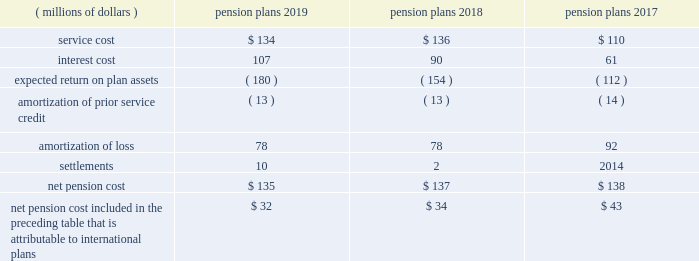Note 9 2014 benefit plans the company has defined benefit pension plans covering certain employees in the united states and certain international locations .
Postretirement healthcare and life insurance benefits provided to qualifying domestic retirees as well as other postretirement benefit plans in international countries are not material .
The measurement date used for the company 2019s employee benefit plans is september 30 .
Effective january 1 , 2018 , the legacy u.s .
Pension plan was frozen to limit the participation of employees who are hired or re-hired by the company , or who transfer employment to the company , on or after january 1 , net pension cost for the years ended september 30 included the following components: .
Net pension cost included in the preceding table that is attributable to international plans $ 32 $ 34 $ 43 the amounts provided above for amortization of prior service credit and amortization of loss represent the reclassifications of prior service credits and net actuarial losses that were recognized in accumulated other comprehensive income ( loss ) in prior periods .
The settlement losses recorded in 2019 and 2018 primarily included lump sum benefit payments associated with the company 2019s u.s .
Supplemental pension plan .
The company recognizes pension settlements when payments from the supplemental plan exceed the sum of service and interest cost components of net periodic pension cost associated with this plan for the fiscal year .
As further discussed in note 2 , upon adopting an accounting standard update on october 1 , 2018 , all components of the company 2019s net periodic pension and postretirement benefit costs , aside from service cost , are recorded to other income ( expense ) , net on its consolidated statements of income , for all periods presented .
Notes to consolidated financial statements 2014 ( continued ) becton , dickinson and company .
What is the percentage increase in service costs from 2017 to 2018? 
Computations: ((136 - 110) / 110)
Answer: 0.23636. 